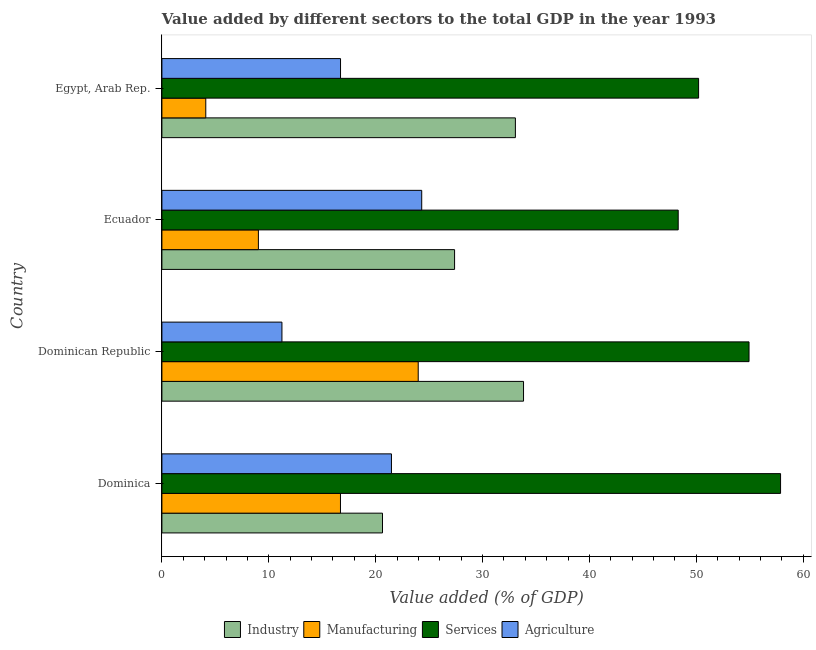How many different coloured bars are there?
Keep it short and to the point. 4. Are the number of bars on each tick of the Y-axis equal?
Offer a terse response. Yes. How many bars are there on the 2nd tick from the top?
Your answer should be very brief. 4. How many bars are there on the 2nd tick from the bottom?
Your answer should be compact. 4. What is the label of the 3rd group of bars from the top?
Ensure brevity in your answer.  Dominican Republic. In how many cases, is the number of bars for a given country not equal to the number of legend labels?
Provide a short and direct response. 0. What is the value added by services sector in Egypt, Arab Rep.?
Provide a short and direct response. 50.21. Across all countries, what is the maximum value added by services sector?
Ensure brevity in your answer.  57.88. Across all countries, what is the minimum value added by services sector?
Your response must be concise. 48.31. In which country was the value added by industrial sector maximum?
Provide a succinct answer. Dominican Republic. In which country was the value added by industrial sector minimum?
Provide a succinct answer. Dominica. What is the total value added by agricultural sector in the graph?
Provide a short and direct response. 73.73. What is the difference between the value added by manufacturing sector in Dominica and that in Egypt, Arab Rep.?
Provide a short and direct response. 12.6. What is the difference between the value added by industrial sector in Dominican Republic and the value added by agricultural sector in Dominica?
Give a very brief answer. 12.36. What is the average value added by services sector per country?
Give a very brief answer. 52.83. What is the difference between the value added by services sector and value added by industrial sector in Ecuador?
Your answer should be compact. 20.92. In how many countries, is the value added by agricultural sector greater than 10 %?
Your answer should be compact. 4. What is the ratio of the value added by manufacturing sector in Dominica to that in Dominican Republic?
Ensure brevity in your answer.  0.7. Is the difference between the value added by manufacturing sector in Dominican Republic and Ecuador greater than the difference between the value added by services sector in Dominican Republic and Ecuador?
Your answer should be compact. Yes. What is the difference between the highest and the second highest value added by agricultural sector?
Make the answer very short. 2.83. What is the difference between the highest and the lowest value added by agricultural sector?
Provide a short and direct response. 13.08. Is the sum of the value added by industrial sector in Ecuador and Egypt, Arab Rep. greater than the maximum value added by agricultural sector across all countries?
Provide a succinct answer. Yes. Is it the case that in every country, the sum of the value added by agricultural sector and value added by manufacturing sector is greater than the sum of value added by services sector and value added by industrial sector?
Provide a short and direct response. No. What does the 3rd bar from the top in Ecuador represents?
Offer a terse response. Manufacturing. What does the 3rd bar from the bottom in Dominica represents?
Your response must be concise. Services. Is it the case that in every country, the sum of the value added by industrial sector and value added by manufacturing sector is greater than the value added by services sector?
Your answer should be compact. No. How many bars are there?
Ensure brevity in your answer.  16. Does the graph contain grids?
Offer a very short reply. No. How many legend labels are there?
Your response must be concise. 4. How are the legend labels stacked?
Your response must be concise. Horizontal. What is the title of the graph?
Make the answer very short. Value added by different sectors to the total GDP in the year 1993. What is the label or title of the X-axis?
Provide a succinct answer. Value added (% of GDP). What is the label or title of the Y-axis?
Your answer should be compact. Country. What is the Value added (% of GDP) in Industry in Dominica?
Give a very brief answer. 20.64. What is the Value added (% of GDP) in Manufacturing in Dominica?
Give a very brief answer. 16.71. What is the Value added (% of GDP) of Services in Dominica?
Offer a terse response. 57.88. What is the Value added (% of GDP) in Agriculture in Dominica?
Give a very brief answer. 21.48. What is the Value added (% of GDP) in Industry in Dominican Republic?
Provide a short and direct response. 33.84. What is the Value added (% of GDP) in Manufacturing in Dominican Republic?
Your response must be concise. 23.98. What is the Value added (% of GDP) of Services in Dominican Republic?
Your answer should be very brief. 54.93. What is the Value added (% of GDP) of Agriculture in Dominican Republic?
Your answer should be very brief. 11.23. What is the Value added (% of GDP) of Industry in Ecuador?
Your answer should be very brief. 27.38. What is the Value added (% of GDP) of Manufacturing in Ecuador?
Provide a short and direct response. 9.03. What is the Value added (% of GDP) in Services in Ecuador?
Ensure brevity in your answer.  48.31. What is the Value added (% of GDP) in Agriculture in Ecuador?
Provide a succinct answer. 24.31. What is the Value added (% of GDP) of Industry in Egypt, Arab Rep.?
Ensure brevity in your answer.  33.07. What is the Value added (% of GDP) in Manufacturing in Egypt, Arab Rep.?
Your answer should be compact. 4.11. What is the Value added (% of GDP) of Services in Egypt, Arab Rep.?
Give a very brief answer. 50.21. What is the Value added (% of GDP) of Agriculture in Egypt, Arab Rep.?
Offer a very short reply. 16.71. Across all countries, what is the maximum Value added (% of GDP) in Industry?
Make the answer very short. 33.84. Across all countries, what is the maximum Value added (% of GDP) in Manufacturing?
Your answer should be very brief. 23.98. Across all countries, what is the maximum Value added (% of GDP) of Services?
Your response must be concise. 57.88. Across all countries, what is the maximum Value added (% of GDP) of Agriculture?
Make the answer very short. 24.31. Across all countries, what is the minimum Value added (% of GDP) of Industry?
Your answer should be compact. 20.64. Across all countries, what is the minimum Value added (% of GDP) of Manufacturing?
Offer a terse response. 4.11. Across all countries, what is the minimum Value added (% of GDP) of Services?
Provide a succinct answer. 48.31. Across all countries, what is the minimum Value added (% of GDP) in Agriculture?
Your response must be concise. 11.23. What is the total Value added (% of GDP) in Industry in the graph?
Your answer should be very brief. 114.93. What is the total Value added (% of GDP) of Manufacturing in the graph?
Give a very brief answer. 53.82. What is the total Value added (% of GDP) of Services in the graph?
Provide a succinct answer. 211.34. What is the total Value added (% of GDP) in Agriculture in the graph?
Keep it short and to the point. 73.73. What is the difference between the Value added (% of GDP) in Industry in Dominica and that in Dominican Republic?
Offer a very short reply. -13.2. What is the difference between the Value added (% of GDP) of Manufacturing in Dominica and that in Dominican Republic?
Give a very brief answer. -7.27. What is the difference between the Value added (% of GDP) in Services in Dominica and that in Dominican Republic?
Your answer should be compact. 2.95. What is the difference between the Value added (% of GDP) in Agriculture in Dominica and that in Dominican Republic?
Give a very brief answer. 10.25. What is the difference between the Value added (% of GDP) of Industry in Dominica and that in Ecuador?
Provide a short and direct response. -6.74. What is the difference between the Value added (% of GDP) in Manufacturing in Dominica and that in Ecuador?
Make the answer very short. 7.68. What is the difference between the Value added (% of GDP) of Services in Dominica and that in Ecuador?
Provide a succinct answer. 9.58. What is the difference between the Value added (% of GDP) in Agriculture in Dominica and that in Ecuador?
Offer a very short reply. -2.83. What is the difference between the Value added (% of GDP) of Industry in Dominica and that in Egypt, Arab Rep.?
Give a very brief answer. -12.43. What is the difference between the Value added (% of GDP) in Manufacturing in Dominica and that in Egypt, Arab Rep.?
Give a very brief answer. 12.6. What is the difference between the Value added (% of GDP) of Services in Dominica and that in Egypt, Arab Rep.?
Offer a very short reply. 7.67. What is the difference between the Value added (% of GDP) in Agriculture in Dominica and that in Egypt, Arab Rep.?
Give a very brief answer. 4.76. What is the difference between the Value added (% of GDP) in Industry in Dominican Republic and that in Ecuador?
Your response must be concise. 6.45. What is the difference between the Value added (% of GDP) in Manufacturing in Dominican Republic and that in Ecuador?
Your answer should be very brief. 14.95. What is the difference between the Value added (% of GDP) in Services in Dominican Republic and that in Ecuador?
Provide a short and direct response. 6.63. What is the difference between the Value added (% of GDP) in Agriculture in Dominican Republic and that in Ecuador?
Give a very brief answer. -13.08. What is the difference between the Value added (% of GDP) of Industry in Dominican Republic and that in Egypt, Arab Rep.?
Ensure brevity in your answer.  0.76. What is the difference between the Value added (% of GDP) in Manufacturing in Dominican Republic and that in Egypt, Arab Rep.?
Your answer should be very brief. 19.88. What is the difference between the Value added (% of GDP) of Services in Dominican Republic and that in Egypt, Arab Rep.?
Your answer should be compact. 4.72. What is the difference between the Value added (% of GDP) in Agriculture in Dominican Republic and that in Egypt, Arab Rep.?
Make the answer very short. -5.48. What is the difference between the Value added (% of GDP) in Industry in Ecuador and that in Egypt, Arab Rep.?
Make the answer very short. -5.69. What is the difference between the Value added (% of GDP) in Manufacturing in Ecuador and that in Egypt, Arab Rep.?
Ensure brevity in your answer.  4.92. What is the difference between the Value added (% of GDP) in Services in Ecuador and that in Egypt, Arab Rep.?
Your response must be concise. -1.91. What is the difference between the Value added (% of GDP) in Agriculture in Ecuador and that in Egypt, Arab Rep.?
Offer a terse response. 7.6. What is the difference between the Value added (% of GDP) of Industry in Dominica and the Value added (% of GDP) of Manufacturing in Dominican Republic?
Offer a very short reply. -3.34. What is the difference between the Value added (% of GDP) in Industry in Dominica and the Value added (% of GDP) in Services in Dominican Republic?
Give a very brief answer. -34.29. What is the difference between the Value added (% of GDP) of Industry in Dominica and the Value added (% of GDP) of Agriculture in Dominican Republic?
Offer a very short reply. 9.41. What is the difference between the Value added (% of GDP) in Manufacturing in Dominica and the Value added (% of GDP) in Services in Dominican Republic?
Your answer should be compact. -38.23. What is the difference between the Value added (% of GDP) of Manufacturing in Dominica and the Value added (% of GDP) of Agriculture in Dominican Republic?
Your answer should be compact. 5.48. What is the difference between the Value added (% of GDP) of Services in Dominica and the Value added (% of GDP) of Agriculture in Dominican Republic?
Give a very brief answer. 46.65. What is the difference between the Value added (% of GDP) of Industry in Dominica and the Value added (% of GDP) of Manufacturing in Ecuador?
Your response must be concise. 11.61. What is the difference between the Value added (% of GDP) in Industry in Dominica and the Value added (% of GDP) in Services in Ecuador?
Your response must be concise. -27.67. What is the difference between the Value added (% of GDP) of Industry in Dominica and the Value added (% of GDP) of Agriculture in Ecuador?
Your response must be concise. -3.67. What is the difference between the Value added (% of GDP) of Manufacturing in Dominica and the Value added (% of GDP) of Services in Ecuador?
Provide a short and direct response. -31.6. What is the difference between the Value added (% of GDP) of Manufacturing in Dominica and the Value added (% of GDP) of Agriculture in Ecuador?
Offer a very short reply. -7.6. What is the difference between the Value added (% of GDP) of Services in Dominica and the Value added (% of GDP) of Agriculture in Ecuador?
Offer a terse response. 33.57. What is the difference between the Value added (% of GDP) of Industry in Dominica and the Value added (% of GDP) of Manufacturing in Egypt, Arab Rep.?
Ensure brevity in your answer.  16.53. What is the difference between the Value added (% of GDP) in Industry in Dominica and the Value added (% of GDP) in Services in Egypt, Arab Rep.?
Your response must be concise. -29.57. What is the difference between the Value added (% of GDP) in Industry in Dominica and the Value added (% of GDP) in Agriculture in Egypt, Arab Rep.?
Your answer should be compact. 3.93. What is the difference between the Value added (% of GDP) of Manufacturing in Dominica and the Value added (% of GDP) of Services in Egypt, Arab Rep.?
Give a very brief answer. -33.51. What is the difference between the Value added (% of GDP) of Manufacturing in Dominica and the Value added (% of GDP) of Agriculture in Egypt, Arab Rep.?
Offer a very short reply. -0. What is the difference between the Value added (% of GDP) in Services in Dominica and the Value added (% of GDP) in Agriculture in Egypt, Arab Rep.?
Keep it short and to the point. 41.17. What is the difference between the Value added (% of GDP) of Industry in Dominican Republic and the Value added (% of GDP) of Manufacturing in Ecuador?
Your answer should be compact. 24.81. What is the difference between the Value added (% of GDP) of Industry in Dominican Republic and the Value added (% of GDP) of Services in Ecuador?
Your answer should be very brief. -14.47. What is the difference between the Value added (% of GDP) in Industry in Dominican Republic and the Value added (% of GDP) in Agriculture in Ecuador?
Keep it short and to the point. 9.53. What is the difference between the Value added (% of GDP) of Manufacturing in Dominican Republic and the Value added (% of GDP) of Services in Ecuador?
Keep it short and to the point. -24.33. What is the difference between the Value added (% of GDP) in Manufacturing in Dominican Republic and the Value added (% of GDP) in Agriculture in Ecuador?
Provide a succinct answer. -0.33. What is the difference between the Value added (% of GDP) of Services in Dominican Republic and the Value added (% of GDP) of Agriculture in Ecuador?
Keep it short and to the point. 30.62. What is the difference between the Value added (% of GDP) of Industry in Dominican Republic and the Value added (% of GDP) of Manufacturing in Egypt, Arab Rep.?
Ensure brevity in your answer.  29.73. What is the difference between the Value added (% of GDP) in Industry in Dominican Republic and the Value added (% of GDP) in Services in Egypt, Arab Rep.?
Make the answer very short. -16.38. What is the difference between the Value added (% of GDP) of Industry in Dominican Republic and the Value added (% of GDP) of Agriculture in Egypt, Arab Rep.?
Offer a very short reply. 17.12. What is the difference between the Value added (% of GDP) in Manufacturing in Dominican Republic and the Value added (% of GDP) in Services in Egypt, Arab Rep.?
Provide a short and direct response. -26.23. What is the difference between the Value added (% of GDP) in Manufacturing in Dominican Republic and the Value added (% of GDP) in Agriculture in Egypt, Arab Rep.?
Your response must be concise. 7.27. What is the difference between the Value added (% of GDP) in Services in Dominican Republic and the Value added (% of GDP) in Agriculture in Egypt, Arab Rep.?
Offer a very short reply. 38.22. What is the difference between the Value added (% of GDP) of Industry in Ecuador and the Value added (% of GDP) of Manufacturing in Egypt, Arab Rep.?
Provide a short and direct response. 23.28. What is the difference between the Value added (% of GDP) of Industry in Ecuador and the Value added (% of GDP) of Services in Egypt, Arab Rep.?
Ensure brevity in your answer.  -22.83. What is the difference between the Value added (% of GDP) in Industry in Ecuador and the Value added (% of GDP) in Agriculture in Egypt, Arab Rep.?
Keep it short and to the point. 10.67. What is the difference between the Value added (% of GDP) of Manufacturing in Ecuador and the Value added (% of GDP) of Services in Egypt, Arab Rep.?
Provide a succinct answer. -41.19. What is the difference between the Value added (% of GDP) of Manufacturing in Ecuador and the Value added (% of GDP) of Agriculture in Egypt, Arab Rep.?
Provide a short and direct response. -7.68. What is the difference between the Value added (% of GDP) of Services in Ecuador and the Value added (% of GDP) of Agriculture in Egypt, Arab Rep.?
Your response must be concise. 31.59. What is the average Value added (% of GDP) in Industry per country?
Make the answer very short. 28.73. What is the average Value added (% of GDP) of Manufacturing per country?
Offer a very short reply. 13.46. What is the average Value added (% of GDP) in Services per country?
Make the answer very short. 52.83. What is the average Value added (% of GDP) in Agriculture per country?
Your answer should be very brief. 18.43. What is the difference between the Value added (% of GDP) of Industry and Value added (% of GDP) of Manufacturing in Dominica?
Offer a terse response. 3.93. What is the difference between the Value added (% of GDP) of Industry and Value added (% of GDP) of Services in Dominica?
Give a very brief answer. -37.24. What is the difference between the Value added (% of GDP) of Industry and Value added (% of GDP) of Agriculture in Dominica?
Ensure brevity in your answer.  -0.84. What is the difference between the Value added (% of GDP) of Manufacturing and Value added (% of GDP) of Services in Dominica?
Provide a succinct answer. -41.18. What is the difference between the Value added (% of GDP) in Manufacturing and Value added (% of GDP) in Agriculture in Dominica?
Offer a very short reply. -4.77. What is the difference between the Value added (% of GDP) of Services and Value added (% of GDP) of Agriculture in Dominica?
Make the answer very short. 36.41. What is the difference between the Value added (% of GDP) in Industry and Value added (% of GDP) in Manufacturing in Dominican Republic?
Your answer should be very brief. 9.85. What is the difference between the Value added (% of GDP) of Industry and Value added (% of GDP) of Services in Dominican Republic?
Keep it short and to the point. -21.1. What is the difference between the Value added (% of GDP) of Industry and Value added (% of GDP) of Agriculture in Dominican Republic?
Give a very brief answer. 22.6. What is the difference between the Value added (% of GDP) in Manufacturing and Value added (% of GDP) in Services in Dominican Republic?
Provide a succinct answer. -30.95. What is the difference between the Value added (% of GDP) in Manufacturing and Value added (% of GDP) in Agriculture in Dominican Republic?
Your response must be concise. 12.75. What is the difference between the Value added (% of GDP) in Services and Value added (% of GDP) in Agriculture in Dominican Republic?
Offer a very short reply. 43.7. What is the difference between the Value added (% of GDP) in Industry and Value added (% of GDP) in Manufacturing in Ecuador?
Your answer should be compact. 18.36. What is the difference between the Value added (% of GDP) of Industry and Value added (% of GDP) of Services in Ecuador?
Your answer should be very brief. -20.92. What is the difference between the Value added (% of GDP) of Industry and Value added (% of GDP) of Agriculture in Ecuador?
Provide a short and direct response. 3.07. What is the difference between the Value added (% of GDP) in Manufacturing and Value added (% of GDP) in Services in Ecuador?
Provide a succinct answer. -39.28. What is the difference between the Value added (% of GDP) of Manufacturing and Value added (% of GDP) of Agriculture in Ecuador?
Offer a terse response. -15.28. What is the difference between the Value added (% of GDP) of Services and Value added (% of GDP) of Agriculture in Ecuador?
Give a very brief answer. 24. What is the difference between the Value added (% of GDP) in Industry and Value added (% of GDP) in Manufacturing in Egypt, Arab Rep.?
Offer a terse response. 28.97. What is the difference between the Value added (% of GDP) of Industry and Value added (% of GDP) of Services in Egypt, Arab Rep.?
Your answer should be compact. -17.14. What is the difference between the Value added (% of GDP) of Industry and Value added (% of GDP) of Agriculture in Egypt, Arab Rep.?
Your answer should be very brief. 16.36. What is the difference between the Value added (% of GDP) in Manufacturing and Value added (% of GDP) in Services in Egypt, Arab Rep.?
Ensure brevity in your answer.  -46.11. What is the difference between the Value added (% of GDP) of Manufacturing and Value added (% of GDP) of Agriculture in Egypt, Arab Rep.?
Offer a very short reply. -12.61. What is the difference between the Value added (% of GDP) in Services and Value added (% of GDP) in Agriculture in Egypt, Arab Rep.?
Make the answer very short. 33.5. What is the ratio of the Value added (% of GDP) in Industry in Dominica to that in Dominican Republic?
Give a very brief answer. 0.61. What is the ratio of the Value added (% of GDP) of Manufacturing in Dominica to that in Dominican Republic?
Your response must be concise. 0.7. What is the ratio of the Value added (% of GDP) in Services in Dominica to that in Dominican Republic?
Offer a terse response. 1.05. What is the ratio of the Value added (% of GDP) in Agriculture in Dominica to that in Dominican Republic?
Offer a very short reply. 1.91. What is the ratio of the Value added (% of GDP) in Industry in Dominica to that in Ecuador?
Your answer should be very brief. 0.75. What is the ratio of the Value added (% of GDP) of Manufacturing in Dominica to that in Ecuador?
Your response must be concise. 1.85. What is the ratio of the Value added (% of GDP) of Services in Dominica to that in Ecuador?
Give a very brief answer. 1.2. What is the ratio of the Value added (% of GDP) of Agriculture in Dominica to that in Ecuador?
Your answer should be very brief. 0.88. What is the ratio of the Value added (% of GDP) in Industry in Dominica to that in Egypt, Arab Rep.?
Offer a very short reply. 0.62. What is the ratio of the Value added (% of GDP) of Manufacturing in Dominica to that in Egypt, Arab Rep.?
Provide a succinct answer. 4.07. What is the ratio of the Value added (% of GDP) in Services in Dominica to that in Egypt, Arab Rep.?
Keep it short and to the point. 1.15. What is the ratio of the Value added (% of GDP) of Agriculture in Dominica to that in Egypt, Arab Rep.?
Your response must be concise. 1.29. What is the ratio of the Value added (% of GDP) of Industry in Dominican Republic to that in Ecuador?
Provide a short and direct response. 1.24. What is the ratio of the Value added (% of GDP) in Manufacturing in Dominican Republic to that in Ecuador?
Provide a short and direct response. 2.66. What is the ratio of the Value added (% of GDP) in Services in Dominican Republic to that in Ecuador?
Ensure brevity in your answer.  1.14. What is the ratio of the Value added (% of GDP) in Agriculture in Dominican Republic to that in Ecuador?
Offer a terse response. 0.46. What is the ratio of the Value added (% of GDP) in Manufacturing in Dominican Republic to that in Egypt, Arab Rep.?
Keep it short and to the point. 5.84. What is the ratio of the Value added (% of GDP) in Services in Dominican Republic to that in Egypt, Arab Rep.?
Make the answer very short. 1.09. What is the ratio of the Value added (% of GDP) of Agriculture in Dominican Republic to that in Egypt, Arab Rep.?
Your answer should be very brief. 0.67. What is the ratio of the Value added (% of GDP) in Industry in Ecuador to that in Egypt, Arab Rep.?
Keep it short and to the point. 0.83. What is the ratio of the Value added (% of GDP) of Manufacturing in Ecuador to that in Egypt, Arab Rep.?
Keep it short and to the point. 2.2. What is the ratio of the Value added (% of GDP) in Services in Ecuador to that in Egypt, Arab Rep.?
Your answer should be very brief. 0.96. What is the ratio of the Value added (% of GDP) of Agriculture in Ecuador to that in Egypt, Arab Rep.?
Keep it short and to the point. 1.45. What is the difference between the highest and the second highest Value added (% of GDP) in Industry?
Your response must be concise. 0.76. What is the difference between the highest and the second highest Value added (% of GDP) in Manufacturing?
Provide a short and direct response. 7.27. What is the difference between the highest and the second highest Value added (% of GDP) of Services?
Offer a very short reply. 2.95. What is the difference between the highest and the second highest Value added (% of GDP) in Agriculture?
Offer a very short reply. 2.83. What is the difference between the highest and the lowest Value added (% of GDP) of Industry?
Ensure brevity in your answer.  13.2. What is the difference between the highest and the lowest Value added (% of GDP) of Manufacturing?
Provide a succinct answer. 19.88. What is the difference between the highest and the lowest Value added (% of GDP) of Services?
Offer a terse response. 9.58. What is the difference between the highest and the lowest Value added (% of GDP) in Agriculture?
Offer a very short reply. 13.08. 